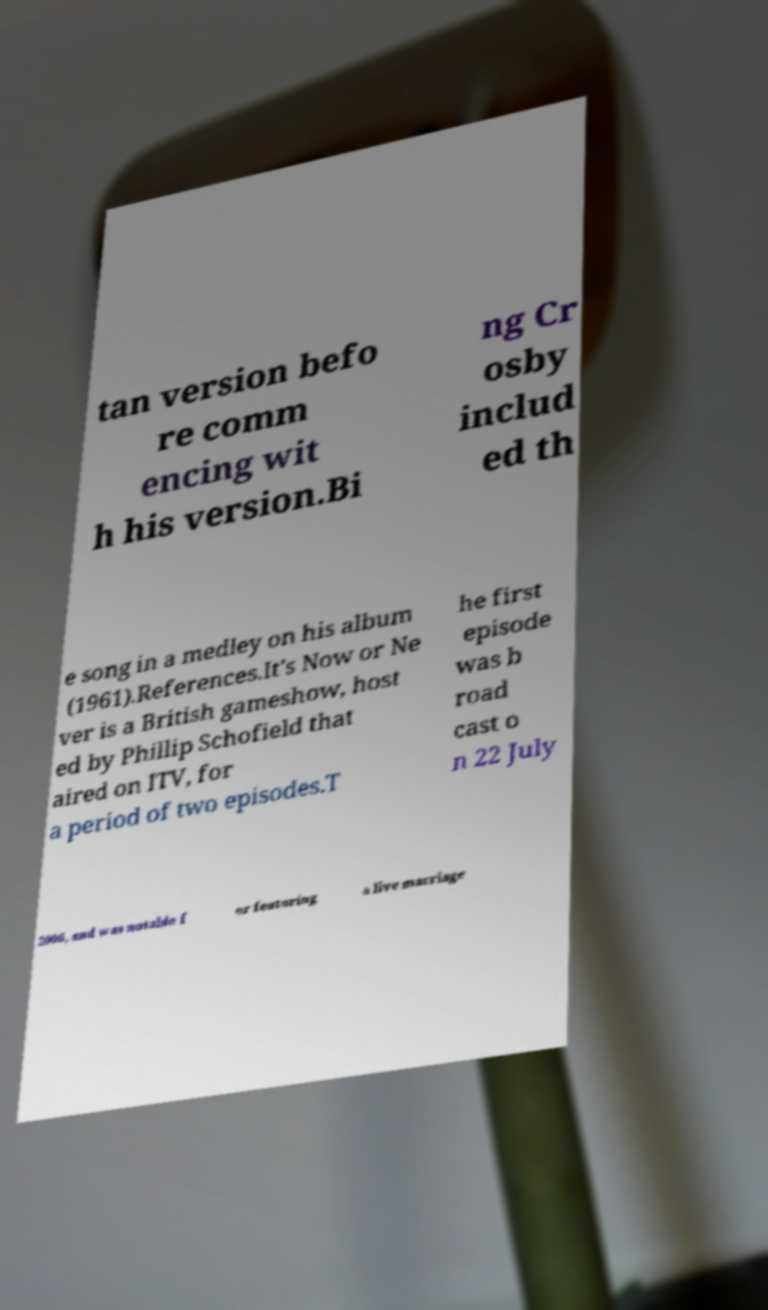I need the written content from this picture converted into text. Can you do that? tan version befo re comm encing wit h his version.Bi ng Cr osby includ ed th e song in a medley on his album (1961).References.It's Now or Ne ver is a British gameshow, host ed by Phillip Schofield that aired on ITV, for a period of two episodes.T he first episode was b road cast o n 22 July 2006, and was notable f or featuring a live marriage 